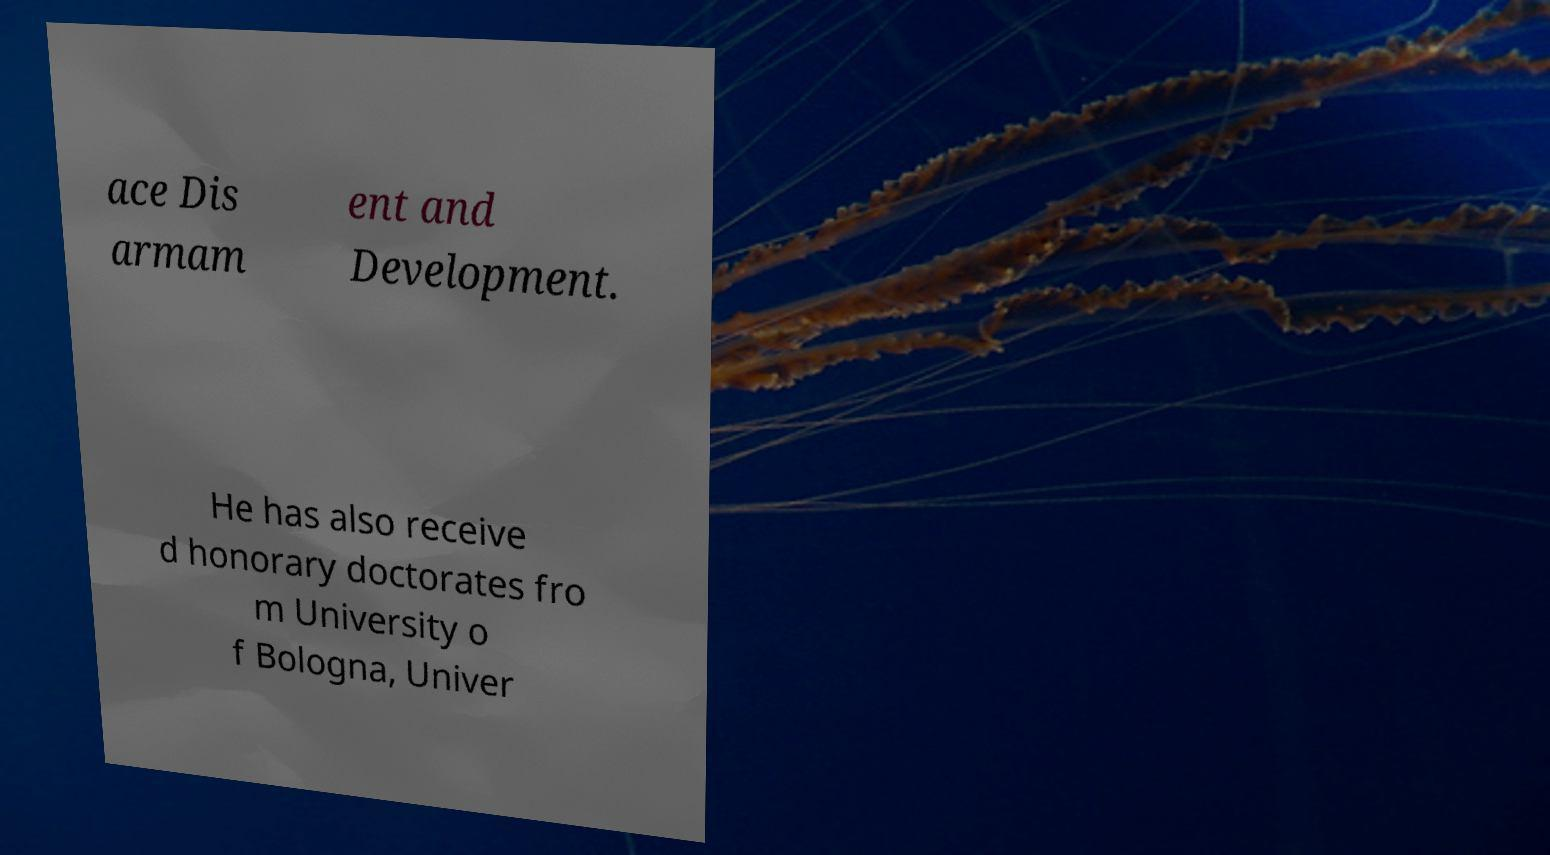Can you read and provide the text displayed in the image?This photo seems to have some interesting text. Can you extract and type it out for me? ace Dis armam ent and Development. He has also receive d honorary doctorates fro m University o f Bologna, Univer 